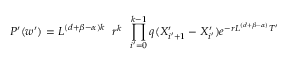<formula> <loc_0><loc_0><loc_500><loc_500>P ^ { \prime } ( w ^ { \prime } ) = L ^ { ( d + \beta - \alpha ) k } \, r ^ { k } \, \prod _ { i ^ { \prime } = 0 } ^ { k - 1 } q ( X _ { i ^ { \prime } + 1 } ^ { \prime } - X _ { i ^ { \prime } } ^ { \prime } ) e ^ { - r L ^ { ( d + \beta - \alpha ) } T ^ { \prime } }</formula> 